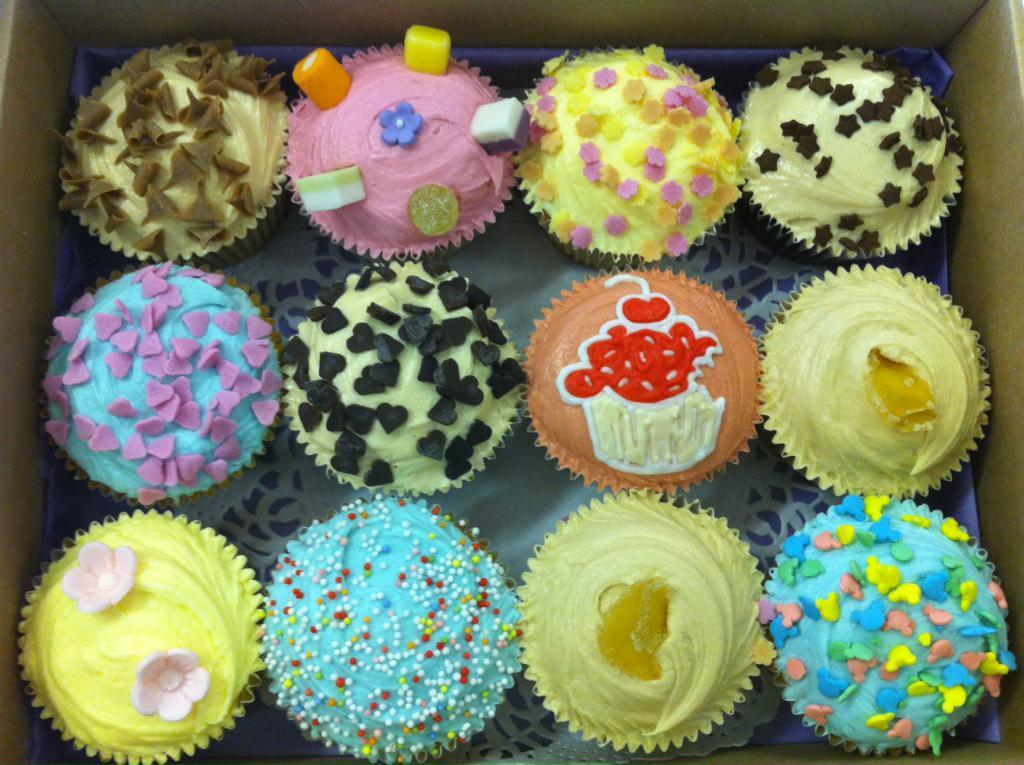What type of food is present in the image? There are cupcakes in the image. How many different types of cupcakes can be seen? The cupcakes come in different varieties. Where are the cupcakes located? The cupcakes are in a box. What type of pickle is used as a topping on the cupcakes in the image? There are no pickles present on the cupcakes in the image. Are the cupcakes being used as a replacement for jeans in the image? The image does not depict any use of cupcakes as a replacement for jeans. 